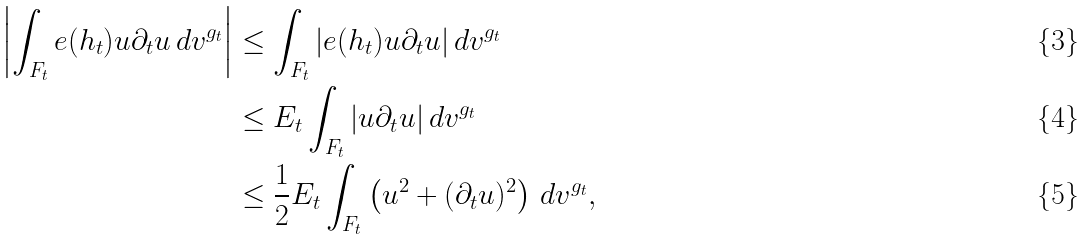<formula> <loc_0><loc_0><loc_500><loc_500>\left | \int _ { F _ { t } } e ( h _ { t } ) u \partial _ { t } u \, d v ^ { g _ { t } } \right | & \leq \int _ { F _ { t } } | e ( h _ { t } ) u \partial _ { t } u | \, d v ^ { g _ { t } } \\ & \leq E _ { t } \int _ { F _ { t } } | u \partial _ { t } u | \, d v ^ { g _ { t } } \\ & \leq \frac { 1 } { 2 } E _ { t } \int _ { F _ { t } } \left ( u ^ { 2 } + ( \partial _ { t } u ) ^ { 2 } \right ) \, d v ^ { g _ { t } } ,</formula> 